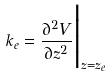Convert formula to latex. <formula><loc_0><loc_0><loc_500><loc_500>k _ { e } = { \frac { \partial ^ { 2 } V } { \partial z ^ { 2 } } } \Big | _ { z = z _ { e } }</formula> 